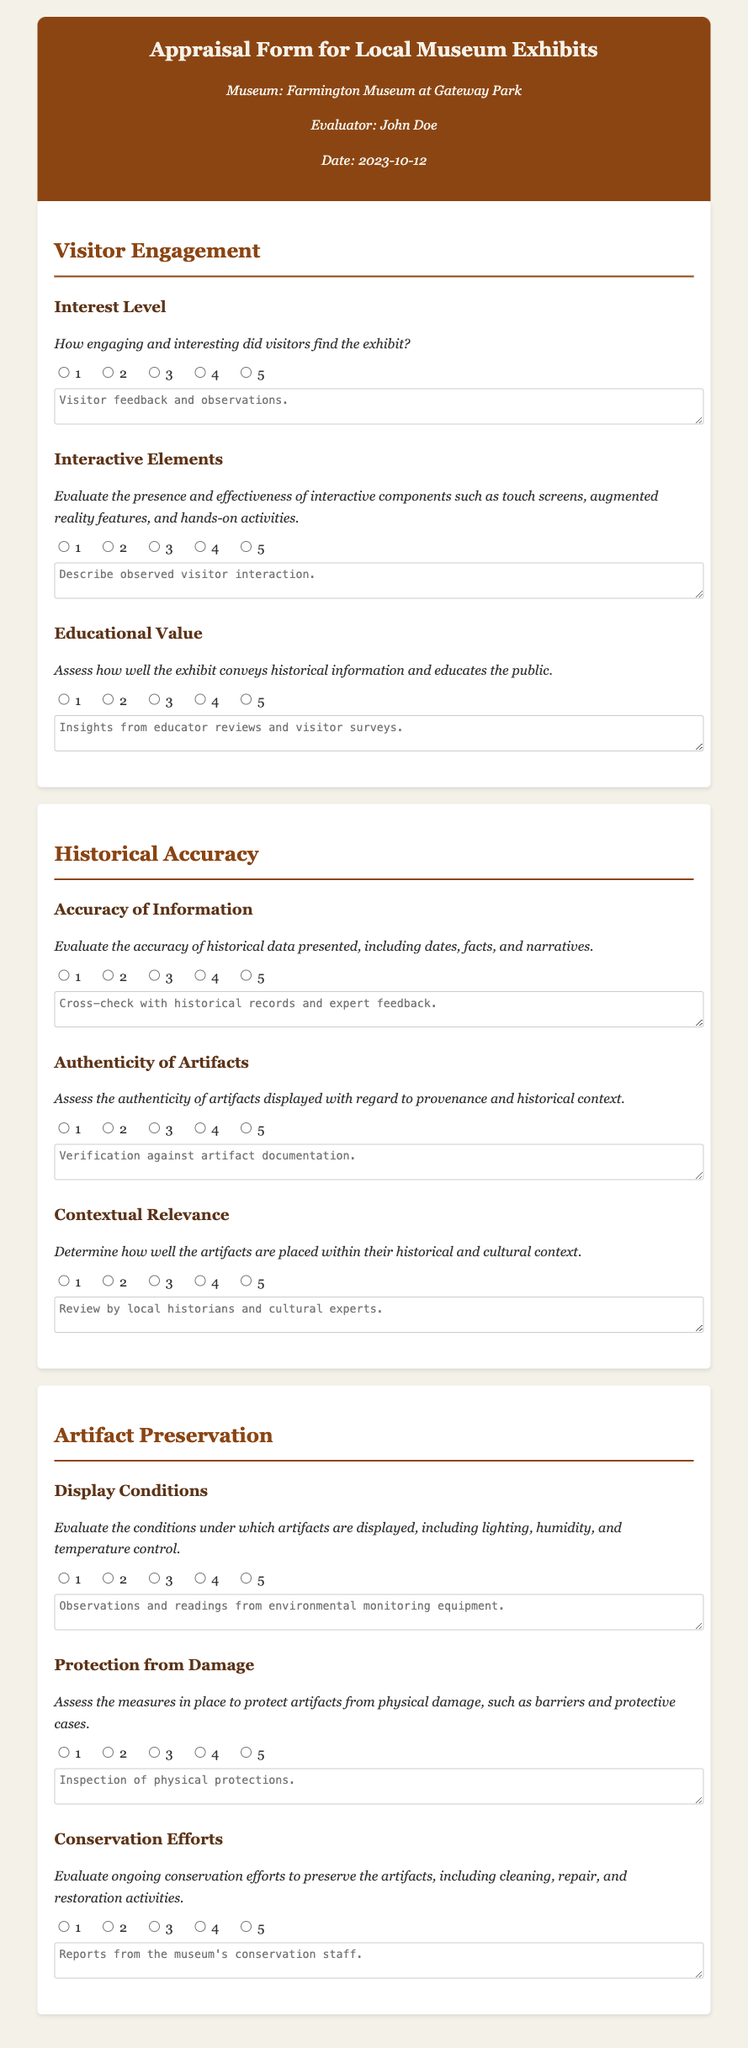What is the title of the document? The title is clearly stated at the top of the document as "Appraisal Form for Local Museum Exhibits".
Answer: Appraisal Form for Local Museum Exhibits Who is the evaluator listed in the form? The evaluator's name is mentioned in the document's meta information section.
Answer: John Doe What date is provided in the appraisal form? The date can be found in the meta information section of the document.
Answer: 2023-10-12 How many criteria are listed under "Visitor Engagement"? The number of criteria can be counted in the section dedicated to "Visitor Engagement".
Answer: 3 What is the highest rating available for the "Interactive Elements"? The document includes a rating scale for every criterion, with the maximum rating specified.
Answer: 5 How many criteria are assessed under "Historical Accuracy"? The number of criteria listed under "Historical Accuracy" can be counted in that section.
Answer: 3 What aspect of artifact preservation is evaluated regarding environmental conditions? The document outlines specific criteria under "Artifact Preservation" which includes this focus.
Answer: Display Conditions What comment section is suggested for visitor feedback? The document specifies a comment section associated with various criteria.
Answer: Visitor feedback and observations What is the purpose of the "Conservation Efforts" criterion? The document explains that this criterion evaluates ongoing preservation activities for artifacts.
Answer: Evaluate ongoing conservation efforts 